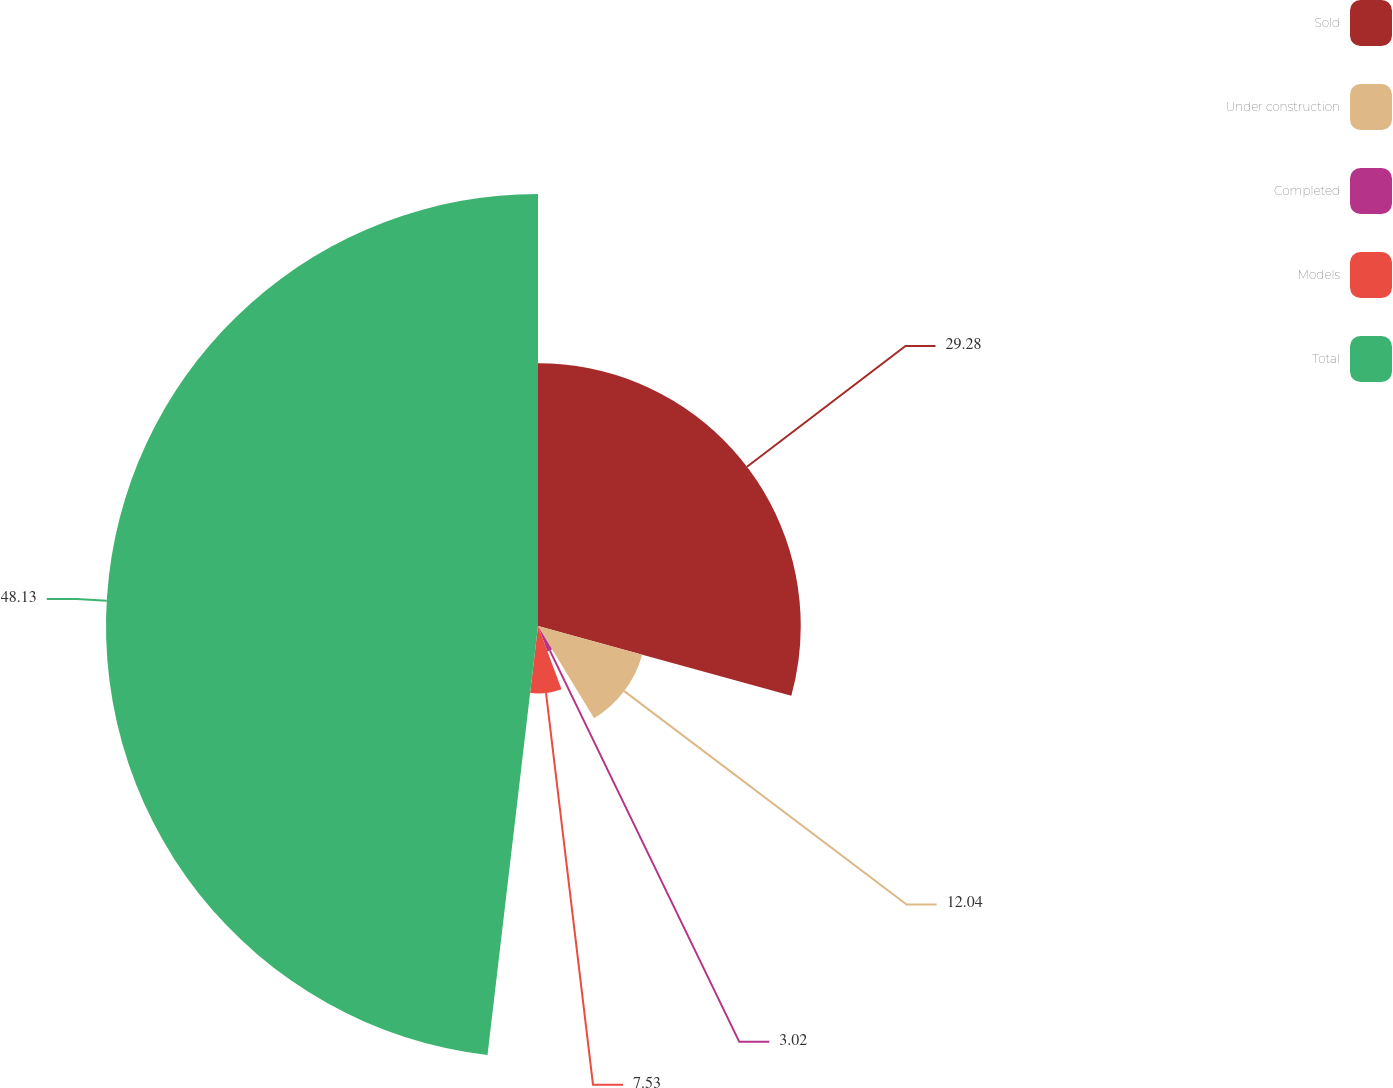<chart> <loc_0><loc_0><loc_500><loc_500><pie_chart><fcel>Sold<fcel>Under construction<fcel>Completed<fcel>Models<fcel>Total<nl><fcel>29.28%<fcel>12.04%<fcel>3.02%<fcel>7.53%<fcel>48.14%<nl></chart> 